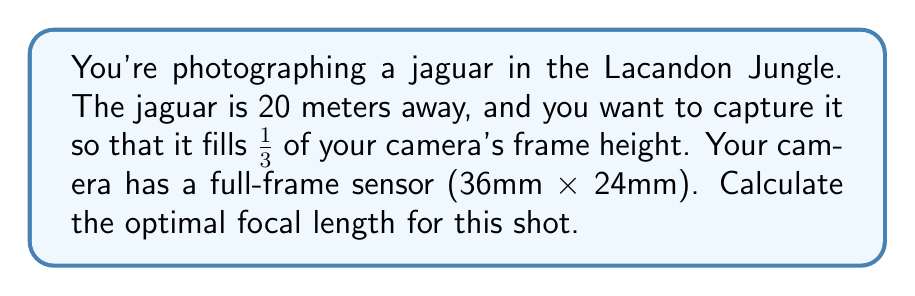Help me with this question. Let's approach this step-by-step:

1) First, we need to determine the desired image height of the jaguar:
   $\frac{1}{3}$ of 24mm (frame height) = 8mm

2) We can use the following formula to calculate the focal length:

   $$f = \frac{h_i \cdot d}{h_s}$$

   Where:
   $f$ = focal length
   $h_i$ = image height (8mm)
   $d$ = subject distance (20,000mm)
   $h_s$ = subject height

3) We need to estimate the height of a jaguar. Let's assume it's about 75cm (750mm) tall.

4) Now we can plug these values into our equation:

   $$f = \frac{8mm \cdot 20,000mm}{750mm}$$

5) Simplify:
   
   $$f = \frac{160,000}{750} = 213.33mm$$

6) In practice, we would round this to the nearest standard focal length, which would be 200mm.
Answer: 200mm 